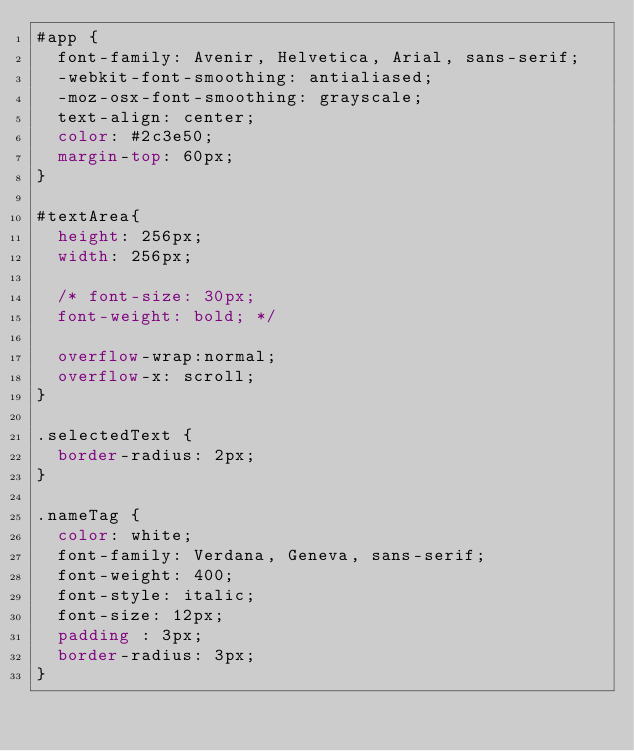<code> <loc_0><loc_0><loc_500><loc_500><_CSS_>#app {
  font-family: Avenir, Helvetica, Arial, sans-serif;
  -webkit-font-smoothing: antialiased;
  -moz-osx-font-smoothing: grayscale;
  text-align: center;
  color: #2c3e50;
  margin-top: 60px;
}

#textArea{
  height: 256px;
  width: 256px;

  /* font-size: 30px;
  font-weight: bold; */

  overflow-wrap:normal;
  overflow-x: scroll;
}

.selectedText {
  border-radius: 2px;
}

.nameTag {
  color: white;
  font-family: Verdana, Geneva, sans-serif;
  font-weight: 400;
  font-style: italic;
  font-size: 12px;
  padding : 3px;
  border-radius: 3px;
}</code> 